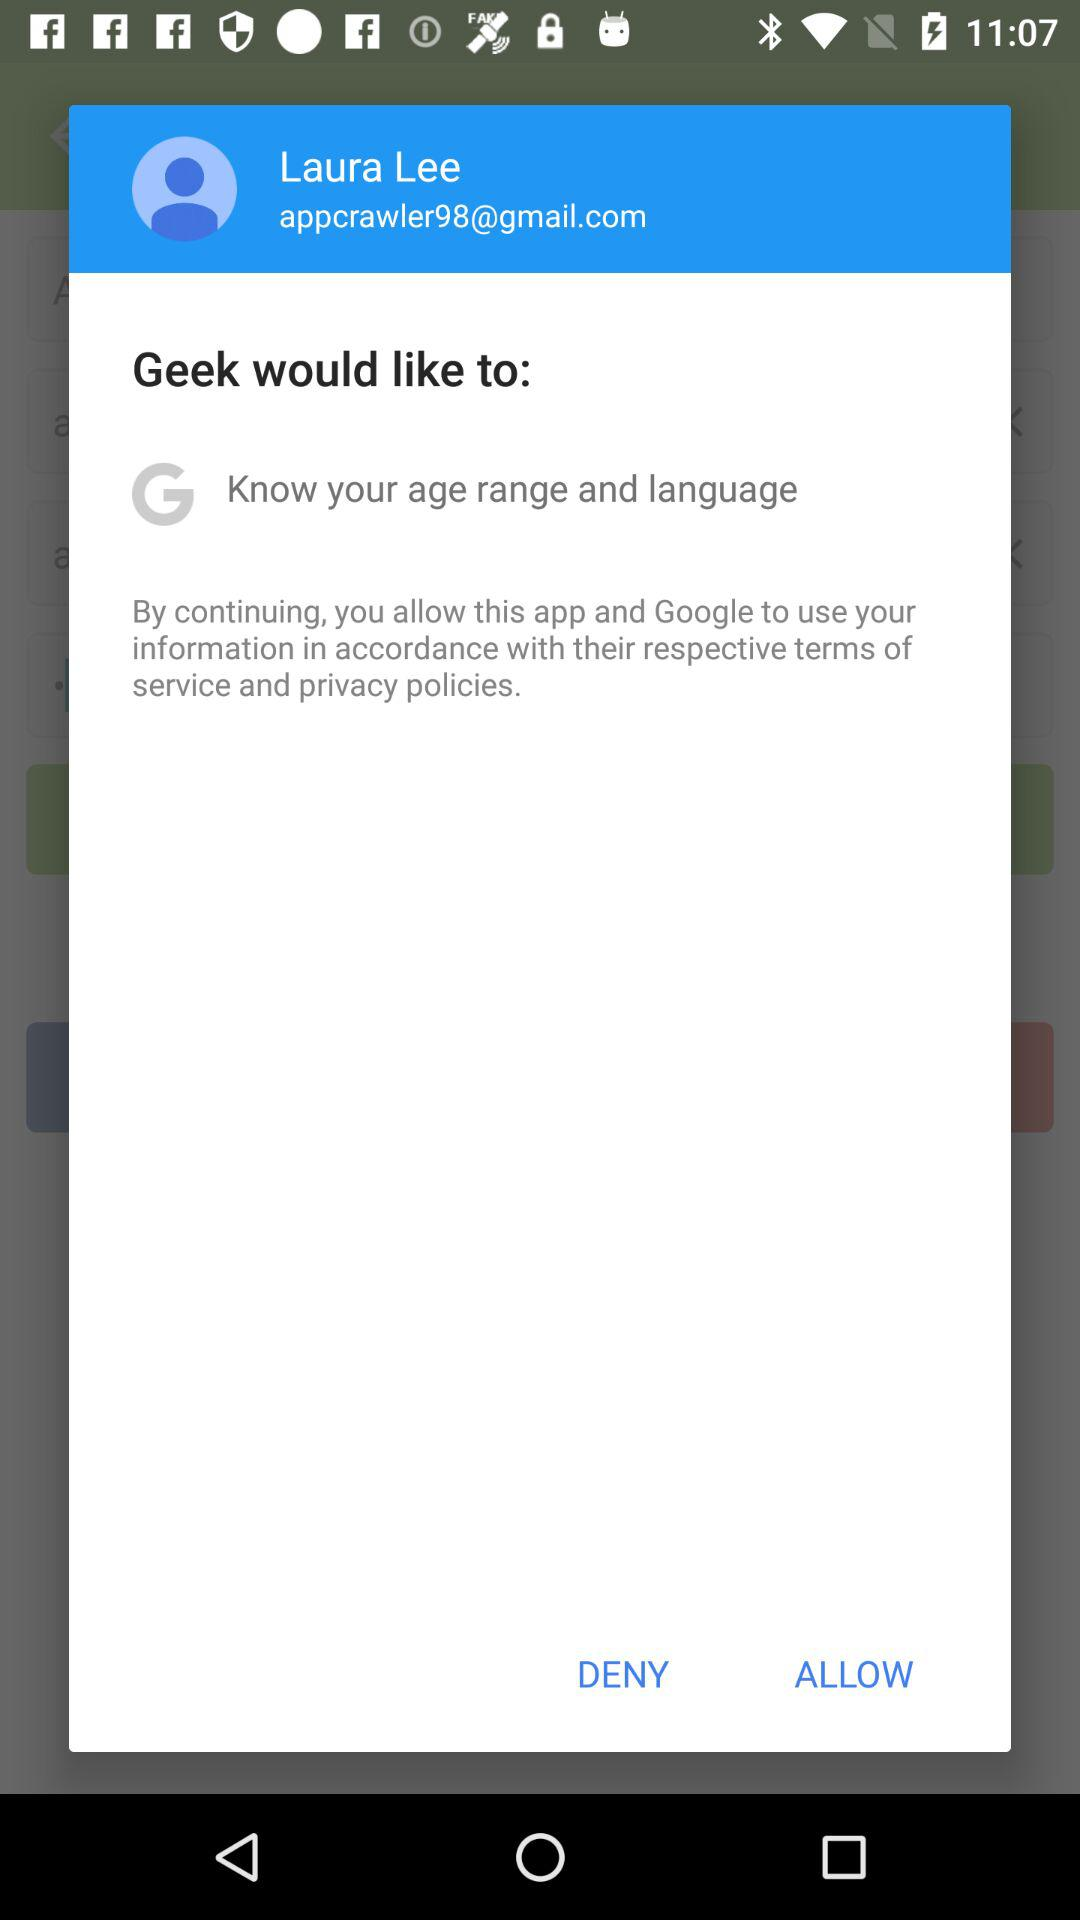What is the user name? The user name is Laura Lee. 